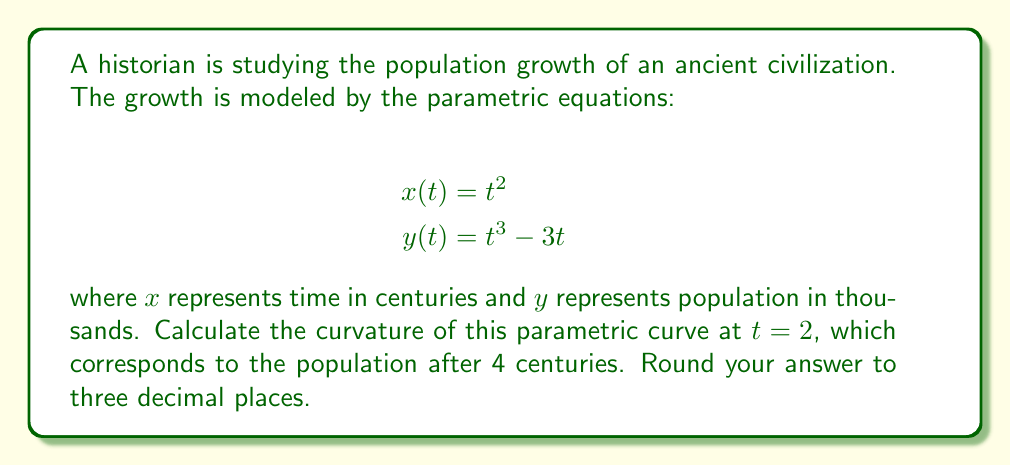Teach me how to tackle this problem. To find the curvature of a parametric curve, we'll use the formula:

$$\kappa = \frac{|x'y'' - y'x''|}{(x'^2 + y'^2)^{3/2}}$$

Let's follow these steps:

1) First, we need to find $x'$, $y'$, $x''$, and $y''$:

   $x' = 2t$
   $y' = 3t^2 - 3$
   $x'' = 2$
   $y'' = 6t$

2) Now, let's substitute $t = 2$ into these expressions:

   $x'(2) = 4$
   $y'(2) = 3(2^2) - 3 = 9$
   $x''(2) = 2$
   $y''(2) = 12$

3) Next, we'll calculate the numerator of the curvature formula:

   $|x'y'' - y'x''| = |4(12) - 9(2)| = |48 - 18| = 30$

4) For the denominator, we first calculate $x'^2 + y'^2$:

   $x'^2 + y'^2 = 4^2 + 9^2 = 16 + 81 = 97$

5) Now we can complete the curvature calculation:

   $$\kappa = \frac{30}{(97)^{3/2}} \approx 0.031$$

6) Rounding to three decimal places gives us 0.031.
Answer: 0.031 